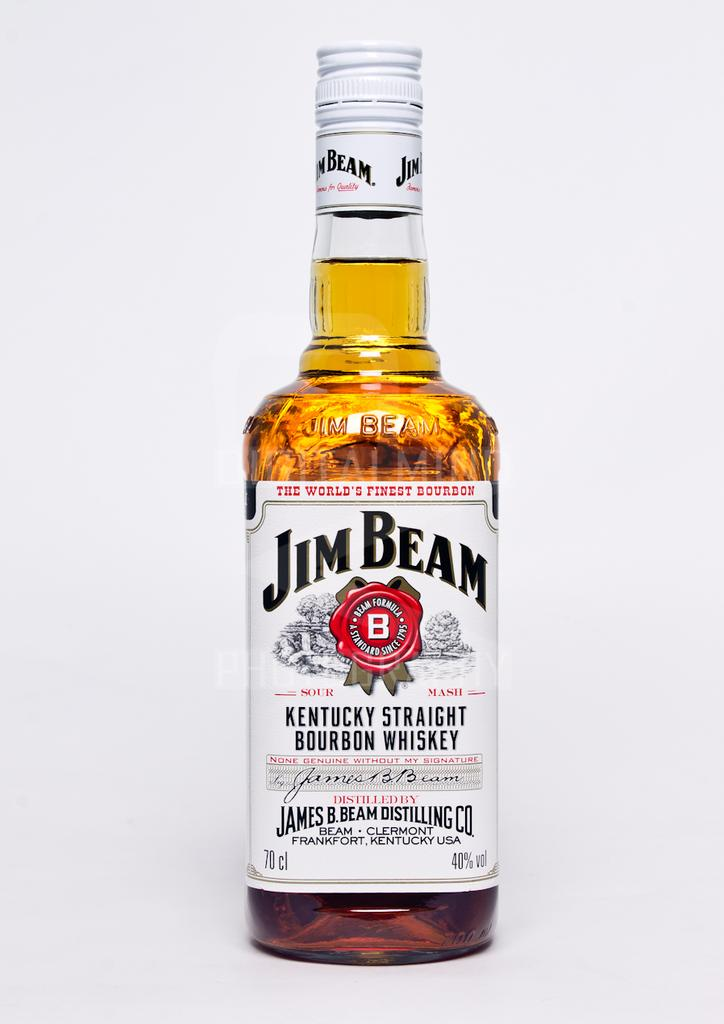Provide a one-sentence caption for the provided image. A bottle of Jim Beam Kentucky Straight Bourbon Whiskey. 